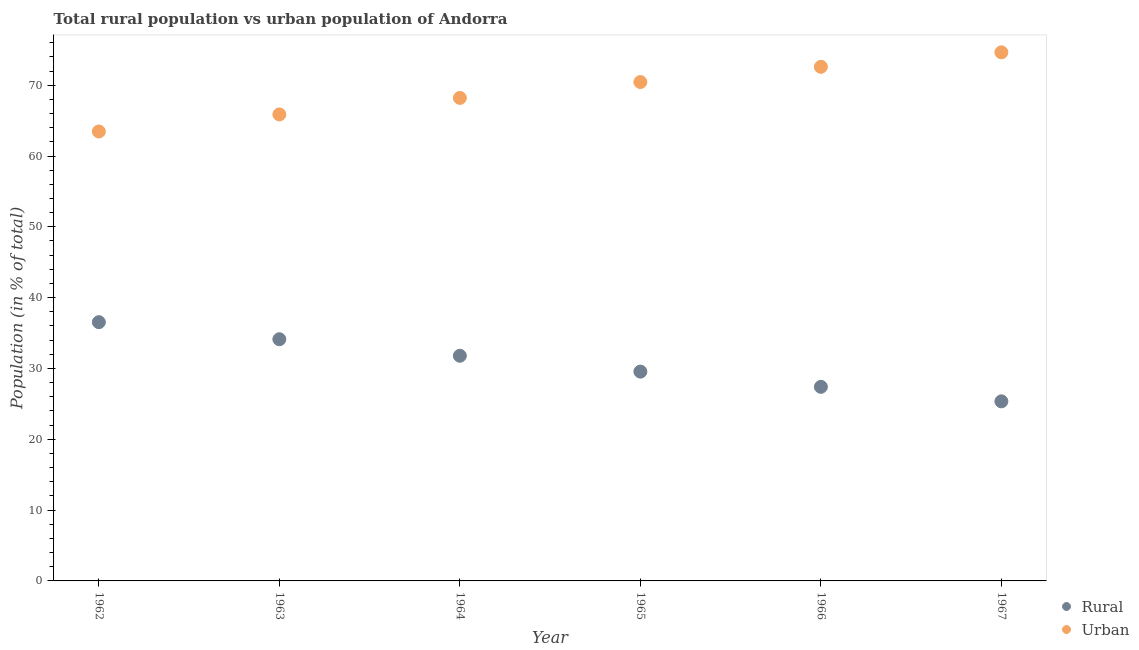Is the number of dotlines equal to the number of legend labels?
Your answer should be compact. Yes. What is the rural population in 1962?
Your answer should be compact. 36.54. Across all years, what is the maximum rural population?
Your response must be concise. 36.54. Across all years, what is the minimum urban population?
Keep it short and to the point. 63.46. In which year was the rural population minimum?
Your answer should be compact. 1967. What is the total urban population in the graph?
Offer a very short reply. 415.22. What is the difference between the urban population in 1965 and that in 1966?
Ensure brevity in your answer.  -2.15. What is the difference between the rural population in 1963 and the urban population in 1967?
Your answer should be very brief. -40.51. What is the average rural population per year?
Your response must be concise. 30.8. In the year 1963, what is the difference between the urban population and rural population?
Keep it short and to the point. 31.74. In how many years, is the urban population greater than 46 %?
Provide a short and direct response. 6. What is the ratio of the rural population in 1962 to that in 1965?
Make the answer very short. 1.24. What is the difference between the highest and the second highest rural population?
Your answer should be very brief. 2.41. What is the difference between the highest and the lowest urban population?
Give a very brief answer. 11.18. Is the sum of the urban population in 1964 and 1965 greater than the maximum rural population across all years?
Offer a very short reply. Yes. Is the rural population strictly greater than the urban population over the years?
Provide a short and direct response. No. Is the rural population strictly less than the urban population over the years?
Your answer should be very brief. Yes. How many years are there in the graph?
Provide a succinct answer. 6. What is the difference between two consecutive major ticks on the Y-axis?
Keep it short and to the point. 10. Are the values on the major ticks of Y-axis written in scientific E-notation?
Provide a succinct answer. No. How many legend labels are there?
Ensure brevity in your answer.  2. How are the legend labels stacked?
Your response must be concise. Vertical. What is the title of the graph?
Give a very brief answer. Total rural population vs urban population of Andorra. What is the label or title of the X-axis?
Give a very brief answer. Year. What is the label or title of the Y-axis?
Provide a succinct answer. Population (in % of total). What is the Population (in % of total) in Rural in 1962?
Your answer should be very brief. 36.54. What is the Population (in % of total) in Urban in 1962?
Provide a short and direct response. 63.46. What is the Population (in % of total) in Rural in 1963?
Give a very brief answer. 34.13. What is the Population (in % of total) in Urban in 1963?
Provide a short and direct response. 65.87. What is the Population (in % of total) in Rural in 1964?
Make the answer very short. 31.8. What is the Population (in % of total) of Urban in 1964?
Give a very brief answer. 68.2. What is the Population (in % of total) of Rural in 1965?
Offer a very short reply. 29.55. What is the Population (in % of total) in Urban in 1965?
Make the answer very short. 70.44. What is the Population (in % of total) in Rural in 1966?
Your answer should be very brief. 27.41. What is the Population (in % of total) of Urban in 1966?
Provide a short and direct response. 72.59. What is the Population (in % of total) of Rural in 1967?
Offer a terse response. 25.36. What is the Population (in % of total) in Urban in 1967?
Ensure brevity in your answer.  74.64. Across all years, what is the maximum Population (in % of total) in Rural?
Provide a short and direct response. 36.54. Across all years, what is the maximum Population (in % of total) of Urban?
Make the answer very short. 74.64. Across all years, what is the minimum Population (in % of total) in Rural?
Ensure brevity in your answer.  25.36. Across all years, what is the minimum Population (in % of total) in Urban?
Your answer should be compact. 63.46. What is the total Population (in % of total) in Rural in the graph?
Your response must be concise. 184.78. What is the total Population (in % of total) of Urban in the graph?
Offer a terse response. 415.22. What is the difference between the Population (in % of total) in Rural in 1962 and that in 1963?
Your response must be concise. 2.41. What is the difference between the Population (in % of total) in Urban in 1962 and that in 1963?
Your answer should be very brief. -2.41. What is the difference between the Population (in % of total) in Rural in 1962 and that in 1964?
Your response must be concise. 4.74. What is the difference between the Population (in % of total) in Urban in 1962 and that in 1964?
Provide a short and direct response. -4.74. What is the difference between the Population (in % of total) in Rural in 1962 and that in 1965?
Offer a terse response. 6.98. What is the difference between the Population (in % of total) in Urban in 1962 and that in 1965?
Offer a terse response. -6.98. What is the difference between the Population (in % of total) in Rural in 1962 and that in 1966?
Provide a short and direct response. 9.13. What is the difference between the Population (in % of total) in Urban in 1962 and that in 1966?
Give a very brief answer. -9.13. What is the difference between the Population (in % of total) in Rural in 1962 and that in 1967?
Provide a short and direct response. 11.18. What is the difference between the Population (in % of total) in Urban in 1962 and that in 1967?
Keep it short and to the point. -11.18. What is the difference between the Population (in % of total) in Rural in 1963 and that in 1964?
Provide a short and direct response. 2.33. What is the difference between the Population (in % of total) in Urban in 1963 and that in 1964?
Ensure brevity in your answer.  -2.33. What is the difference between the Population (in % of total) of Rural in 1963 and that in 1965?
Provide a short and direct response. 4.57. What is the difference between the Population (in % of total) of Urban in 1963 and that in 1965?
Offer a very short reply. -4.57. What is the difference between the Population (in % of total) of Rural in 1963 and that in 1966?
Make the answer very short. 6.72. What is the difference between the Population (in % of total) of Urban in 1963 and that in 1966?
Make the answer very short. -6.72. What is the difference between the Population (in % of total) of Rural in 1963 and that in 1967?
Your response must be concise. 8.77. What is the difference between the Population (in % of total) in Urban in 1963 and that in 1967?
Keep it short and to the point. -8.77. What is the difference between the Population (in % of total) of Rural in 1964 and that in 1965?
Give a very brief answer. 2.24. What is the difference between the Population (in % of total) of Urban in 1964 and that in 1965?
Offer a terse response. -2.24. What is the difference between the Population (in % of total) in Rural in 1964 and that in 1966?
Ensure brevity in your answer.  4.39. What is the difference between the Population (in % of total) of Urban in 1964 and that in 1966?
Provide a short and direct response. -4.39. What is the difference between the Population (in % of total) of Rural in 1964 and that in 1967?
Ensure brevity in your answer.  6.44. What is the difference between the Population (in % of total) of Urban in 1964 and that in 1967?
Ensure brevity in your answer.  -6.44. What is the difference between the Population (in % of total) of Rural in 1965 and that in 1966?
Your answer should be very brief. 2.15. What is the difference between the Population (in % of total) of Urban in 1965 and that in 1966?
Keep it short and to the point. -2.15. What is the difference between the Population (in % of total) of Rural in 1965 and that in 1967?
Provide a succinct answer. 4.2. What is the difference between the Population (in % of total) in Urban in 1965 and that in 1967?
Provide a succinct answer. -4.2. What is the difference between the Population (in % of total) of Rural in 1966 and that in 1967?
Give a very brief answer. 2.05. What is the difference between the Population (in % of total) in Urban in 1966 and that in 1967?
Offer a terse response. -2.05. What is the difference between the Population (in % of total) of Rural in 1962 and the Population (in % of total) of Urban in 1963?
Ensure brevity in your answer.  -29.33. What is the difference between the Population (in % of total) of Rural in 1962 and the Population (in % of total) of Urban in 1964?
Provide a short and direct response. -31.67. What is the difference between the Population (in % of total) in Rural in 1962 and the Population (in % of total) in Urban in 1965?
Offer a very short reply. -33.91. What is the difference between the Population (in % of total) in Rural in 1962 and the Population (in % of total) in Urban in 1966?
Keep it short and to the point. -36.05. What is the difference between the Population (in % of total) in Rural in 1962 and the Population (in % of total) in Urban in 1967?
Make the answer very short. -38.1. What is the difference between the Population (in % of total) in Rural in 1963 and the Population (in % of total) in Urban in 1964?
Make the answer very short. -34.08. What is the difference between the Population (in % of total) of Rural in 1963 and the Population (in % of total) of Urban in 1965?
Make the answer very short. -36.32. What is the difference between the Population (in % of total) of Rural in 1963 and the Population (in % of total) of Urban in 1966?
Give a very brief answer. -38.47. What is the difference between the Population (in % of total) in Rural in 1963 and the Population (in % of total) in Urban in 1967?
Ensure brevity in your answer.  -40.51. What is the difference between the Population (in % of total) in Rural in 1964 and the Population (in % of total) in Urban in 1965?
Offer a very short reply. -38.65. What is the difference between the Population (in % of total) in Rural in 1964 and the Population (in % of total) in Urban in 1966?
Keep it short and to the point. -40.8. What is the difference between the Population (in % of total) of Rural in 1964 and the Population (in % of total) of Urban in 1967?
Your answer should be very brief. -42.85. What is the difference between the Population (in % of total) of Rural in 1965 and the Population (in % of total) of Urban in 1966?
Keep it short and to the point. -43.04. What is the difference between the Population (in % of total) in Rural in 1965 and the Population (in % of total) in Urban in 1967?
Your answer should be compact. -45.09. What is the difference between the Population (in % of total) in Rural in 1966 and the Population (in % of total) in Urban in 1967?
Give a very brief answer. -47.23. What is the average Population (in % of total) of Rural per year?
Offer a very short reply. 30.8. What is the average Population (in % of total) of Urban per year?
Your answer should be very brief. 69.2. In the year 1962, what is the difference between the Population (in % of total) of Rural and Population (in % of total) of Urban?
Offer a terse response. -26.92. In the year 1963, what is the difference between the Population (in % of total) of Rural and Population (in % of total) of Urban?
Your answer should be very brief. -31.74. In the year 1964, what is the difference between the Population (in % of total) in Rural and Population (in % of total) in Urban?
Keep it short and to the point. -36.41. In the year 1965, what is the difference between the Population (in % of total) of Rural and Population (in % of total) of Urban?
Ensure brevity in your answer.  -40.89. In the year 1966, what is the difference between the Population (in % of total) of Rural and Population (in % of total) of Urban?
Offer a very short reply. -45.19. In the year 1967, what is the difference between the Population (in % of total) in Rural and Population (in % of total) in Urban?
Offer a very short reply. -49.28. What is the ratio of the Population (in % of total) in Rural in 1962 to that in 1963?
Ensure brevity in your answer.  1.07. What is the ratio of the Population (in % of total) in Urban in 1962 to that in 1963?
Give a very brief answer. 0.96. What is the ratio of the Population (in % of total) in Rural in 1962 to that in 1964?
Provide a short and direct response. 1.15. What is the ratio of the Population (in % of total) of Urban in 1962 to that in 1964?
Your answer should be compact. 0.93. What is the ratio of the Population (in % of total) in Rural in 1962 to that in 1965?
Provide a succinct answer. 1.24. What is the ratio of the Population (in % of total) of Urban in 1962 to that in 1965?
Offer a very short reply. 0.9. What is the ratio of the Population (in % of total) of Rural in 1962 to that in 1966?
Your response must be concise. 1.33. What is the ratio of the Population (in % of total) of Urban in 1962 to that in 1966?
Provide a short and direct response. 0.87. What is the ratio of the Population (in % of total) in Rural in 1962 to that in 1967?
Offer a terse response. 1.44. What is the ratio of the Population (in % of total) of Urban in 1962 to that in 1967?
Your answer should be compact. 0.85. What is the ratio of the Population (in % of total) in Rural in 1963 to that in 1964?
Give a very brief answer. 1.07. What is the ratio of the Population (in % of total) in Urban in 1963 to that in 1964?
Offer a very short reply. 0.97. What is the ratio of the Population (in % of total) in Rural in 1963 to that in 1965?
Provide a succinct answer. 1.15. What is the ratio of the Population (in % of total) in Urban in 1963 to that in 1965?
Offer a terse response. 0.94. What is the ratio of the Population (in % of total) of Rural in 1963 to that in 1966?
Your answer should be compact. 1.25. What is the ratio of the Population (in % of total) in Urban in 1963 to that in 1966?
Give a very brief answer. 0.91. What is the ratio of the Population (in % of total) of Rural in 1963 to that in 1967?
Provide a short and direct response. 1.35. What is the ratio of the Population (in % of total) in Urban in 1963 to that in 1967?
Offer a very short reply. 0.88. What is the ratio of the Population (in % of total) of Rural in 1964 to that in 1965?
Ensure brevity in your answer.  1.08. What is the ratio of the Population (in % of total) of Urban in 1964 to that in 1965?
Keep it short and to the point. 0.97. What is the ratio of the Population (in % of total) in Rural in 1964 to that in 1966?
Keep it short and to the point. 1.16. What is the ratio of the Population (in % of total) of Urban in 1964 to that in 1966?
Your response must be concise. 0.94. What is the ratio of the Population (in % of total) of Rural in 1964 to that in 1967?
Make the answer very short. 1.25. What is the ratio of the Population (in % of total) in Urban in 1964 to that in 1967?
Provide a succinct answer. 0.91. What is the ratio of the Population (in % of total) of Rural in 1965 to that in 1966?
Your answer should be very brief. 1.08. What is the ratio of the Population (in % of total) in Urban in 1965 to that in 1966?
Your answer should be very brief. 0.97. What is the ratio of the Population (in % of total) of Rural in 1965 to that in 1967?
Provide a succinct answer. 1.17. What is the ratio of the Population (in % of total) of Urban in 1965 to that in 1967?
Offer a very short reply. 0.94. What is the ratio of the Population (in % of total) in Rural in 1966 to that in 1967?
Offer a very short reply. 1.08. What is the ratio of the Population (in % of total) of Urban in 1966 to that in 1967?
Your response must be concise. 0.97. What is the difference between the highest and the second highest Population (in % of total) of Rural?
Provide a short and direct response. 2.41. What is the difference between the highest and the second highest Population (in % of total) of Urban?
Your answer should be very brief. 2.05. What is the difference between the highest and the lowest Population (in % of total) of Rural?
Offer a very short reply. 11.18. What is the difference between the highest and the lowest Population (in % of total) of Urban?
Keep it short and to the point. 11.18. 